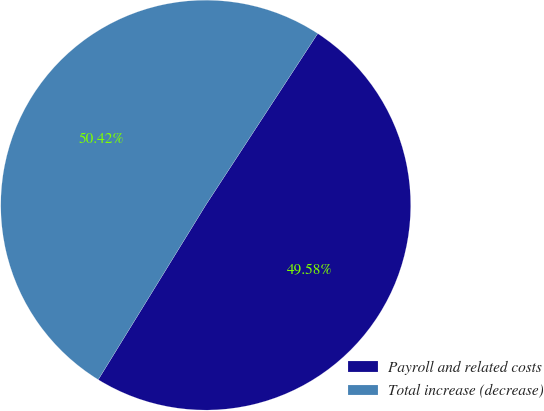Convert chart to OTSL. <chart><loc_0><loc_0><loc_500><loc_500><pie_chart><fcel>Payroll and related costs<fcel>Total increase (decrease)<nl><fcel>49.58%<fcel>50.42%<nl></chart> 